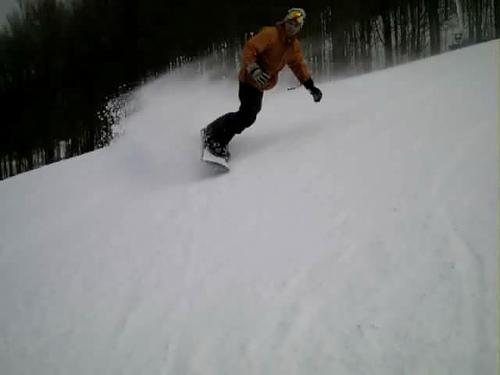Is he moving?
Write a very short answer. Yes. Is the man surfing?
Keep it brief. No. Where is he going?
Write a very short answer. Downhill. 